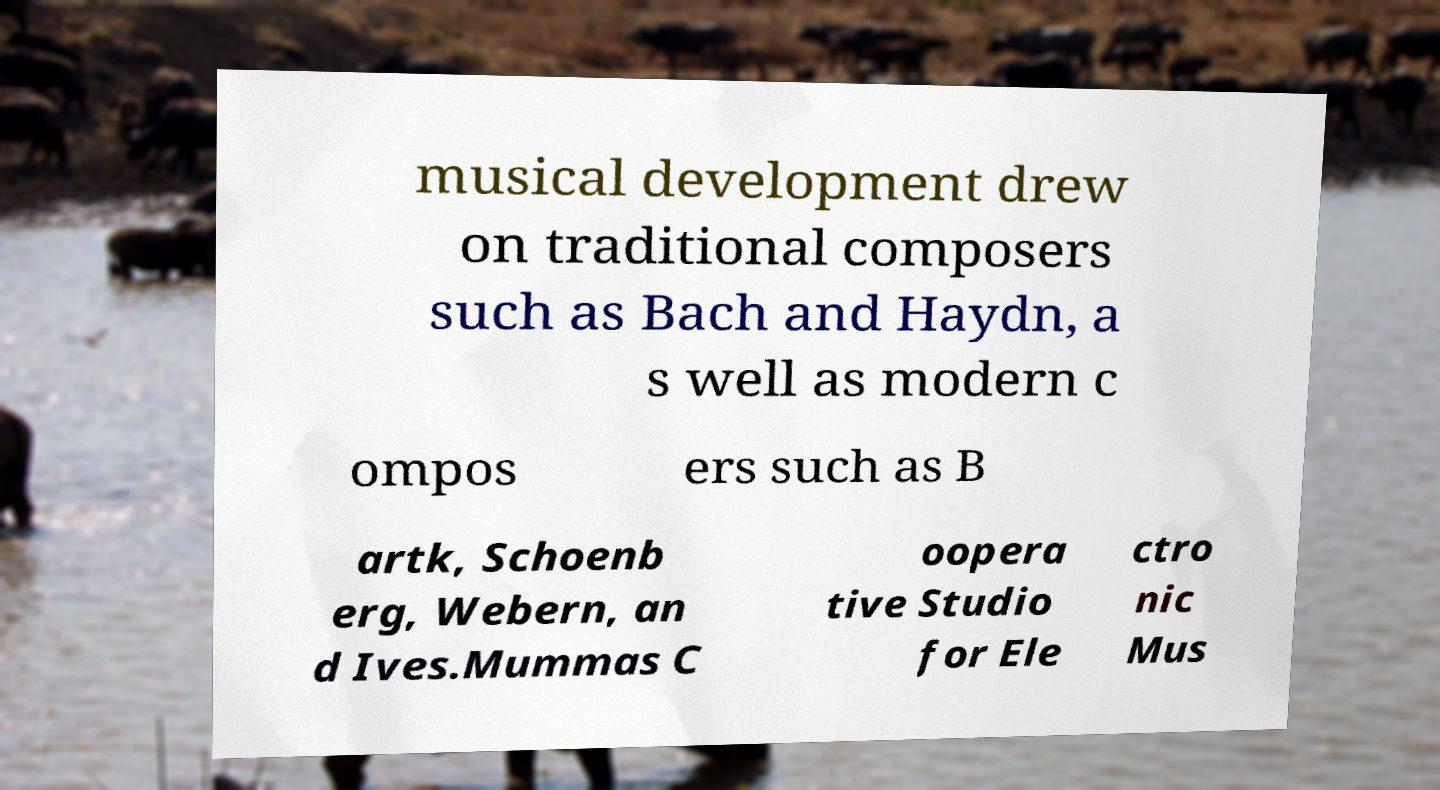There's text embedded in this image that I need extracted. Can you transcribe it verbatim? musical development drew on traditional composers such as Bach and Haydn, a s well as modern c ompos ers such as B artk, Schoenb erg, Webern, an d Ives.Mummas C oopera tive Studio for Ele ctro nic Mus 